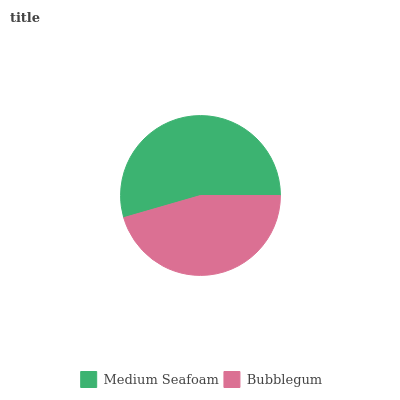Is Bubblegum the minimum?
Answer yes or no. Yes. Is Medium Seafoam the maximum?
Answer yes or no. Yes. Is Bubblegum the maximum?
Answer yes or no. No. Is Medium Seafoam greater than Bubblegum?
Answer yes or no. Yes. Is Bubblegum less than Medium Seafoam?
Answer yes or no. Yes. Is Bubblegum greater than Medium Seafoam?
Answer yes or no. No. Is Medium Seafoam less than Bubblegum?
Answer yes or no. No. Is Medium Seafoam the high median?
Answer yes or no. Yes. Is Bubblegum the low median?
Answer yes or no. Yes. Is Bubblegum the high median?
Answer yes or no. No. Is Medium Seafoam the low median?
Answer yes or no. No. 